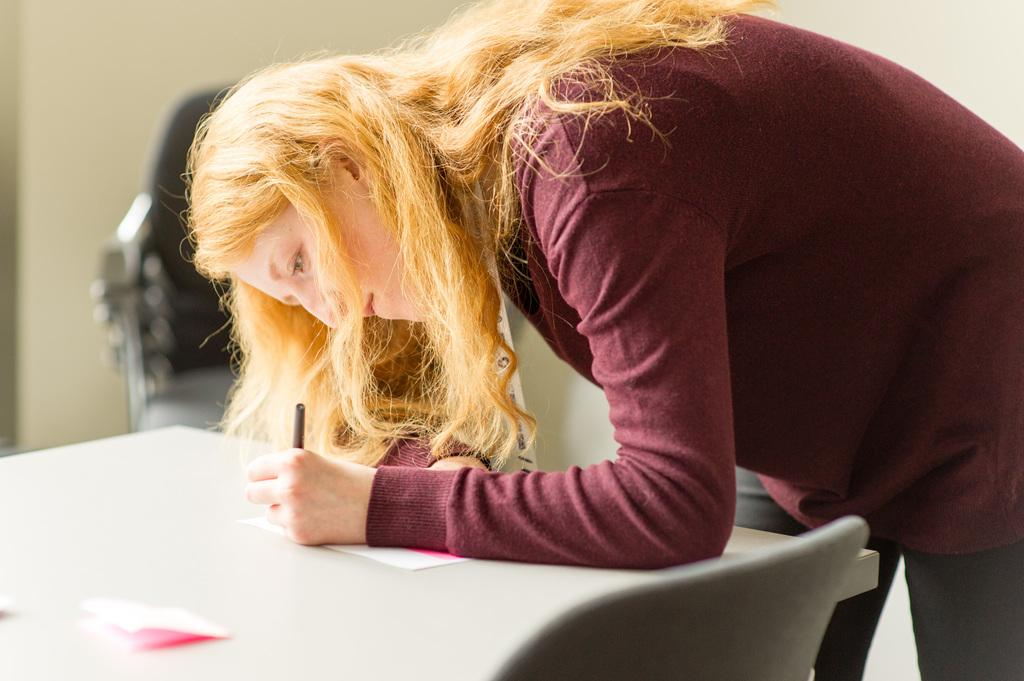Who is the main subject in the image? There is a woman in the image. What is the woman doing in the image? The woman is bending down and writing on a paper. Where is the paper located in the image? The paper is on a table. What is near the table in the image? There is a chair near the table. What type of silver hair can be seen on the woman in the image? There is no mention of the woman's hair color in the provided facts, and therefore we cannot determine if her hair is silver or any other color. Is there a bomb present in the image? There is no mention of a bomb in the provided facts, and therefore we cannot determine if one is present in the image. 